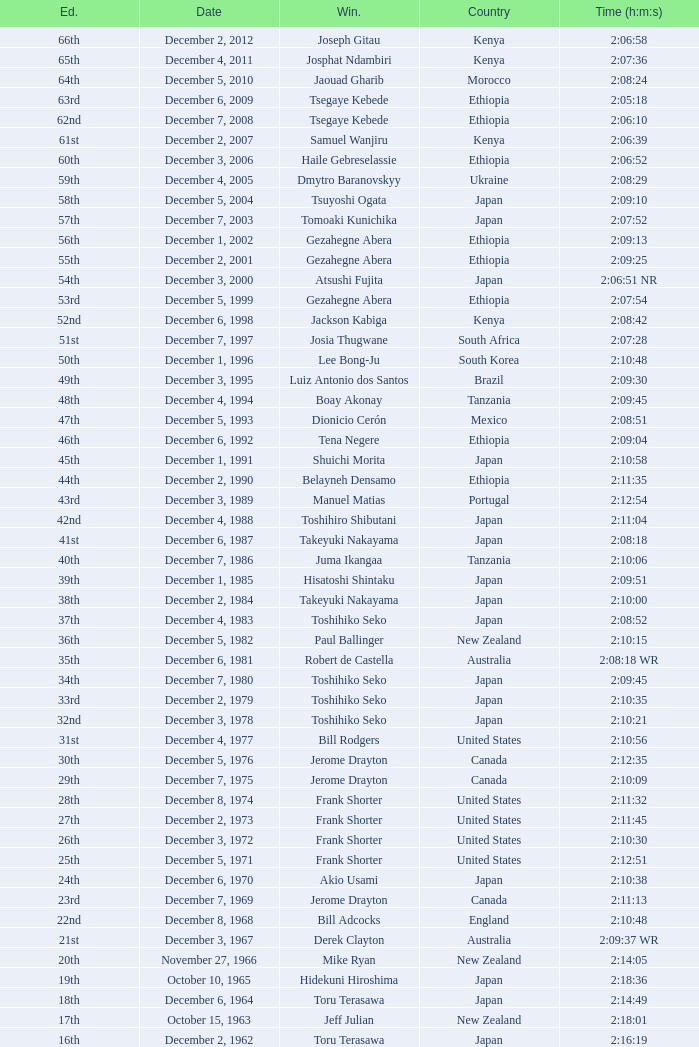What was the nationality of the winner for the 20th Edition? New Zealand. 